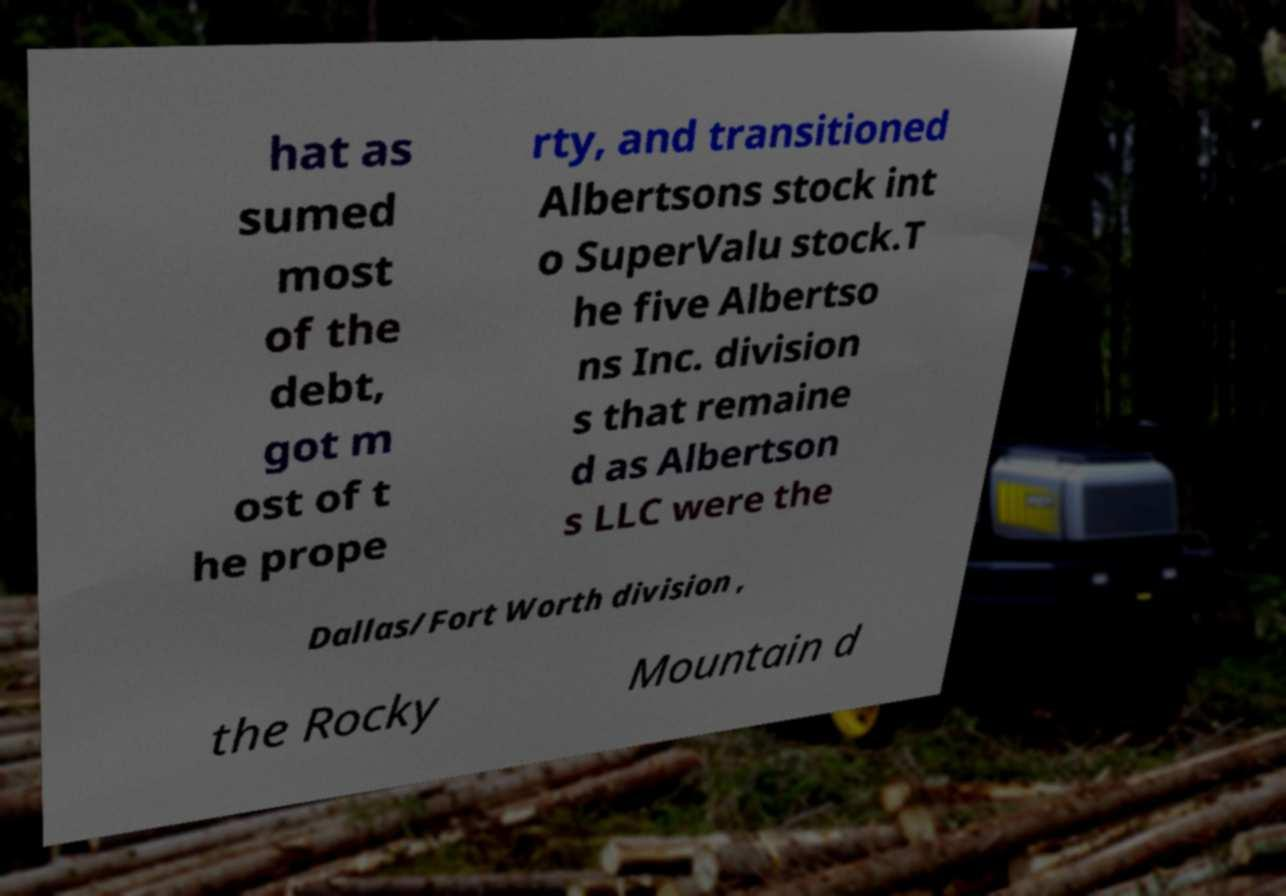Could you assist in decoding the text presented in this image and type it out clearly? hat as sumed most of the debt, got m ost of t he prope rty, and transitioned Albertsons stock int o SuperValu stock.T he five Albertso ns Inc. division s that remaine d as Albertson s LLC were the Dallas/Fort Worth division , the Rocky Mountain d 